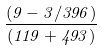Convert formula to latex. <formula><loc_0><loc_0><loc_500><loc_500>\frac { ( 9 - 3 / 3 9 6 ) } { ( 1 1 9 + 4 9 3 ) }</formula> 